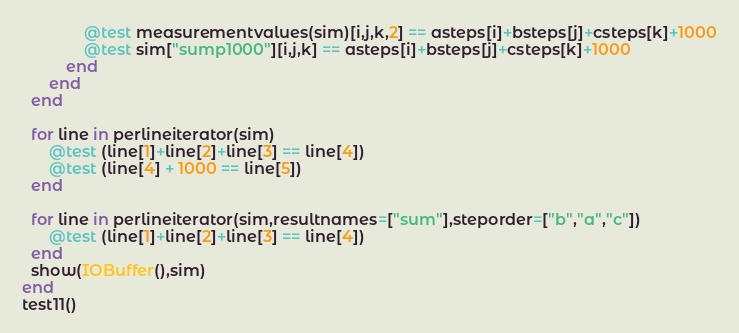<code> <loc_0><loc_0><loc_500><loc_500><_Julia_>              @test measurementvalues(sim)[i,j,k,2] == asteps[i]+bsteps[j]+csteps[k]+1000
              @test sim["sump1000"][i,j,k] == asteps[i]+bsteps[j]+csteps[k]+1000
          end
      end
  end

  for line in perlineiterator(sim)
      @test (line[1]+line[2]+line[3] == line[4])
      @test (line[4] + 1000 == line[5])
  end

  for line in perlineiterator(sim,resultnames=["sum"],steporder=["b","a","c"])
      @test (line[1]+line[2]+line[3] == line[4])
  end
  show(IOBuffer(),sim)
end
test11()
</code> 